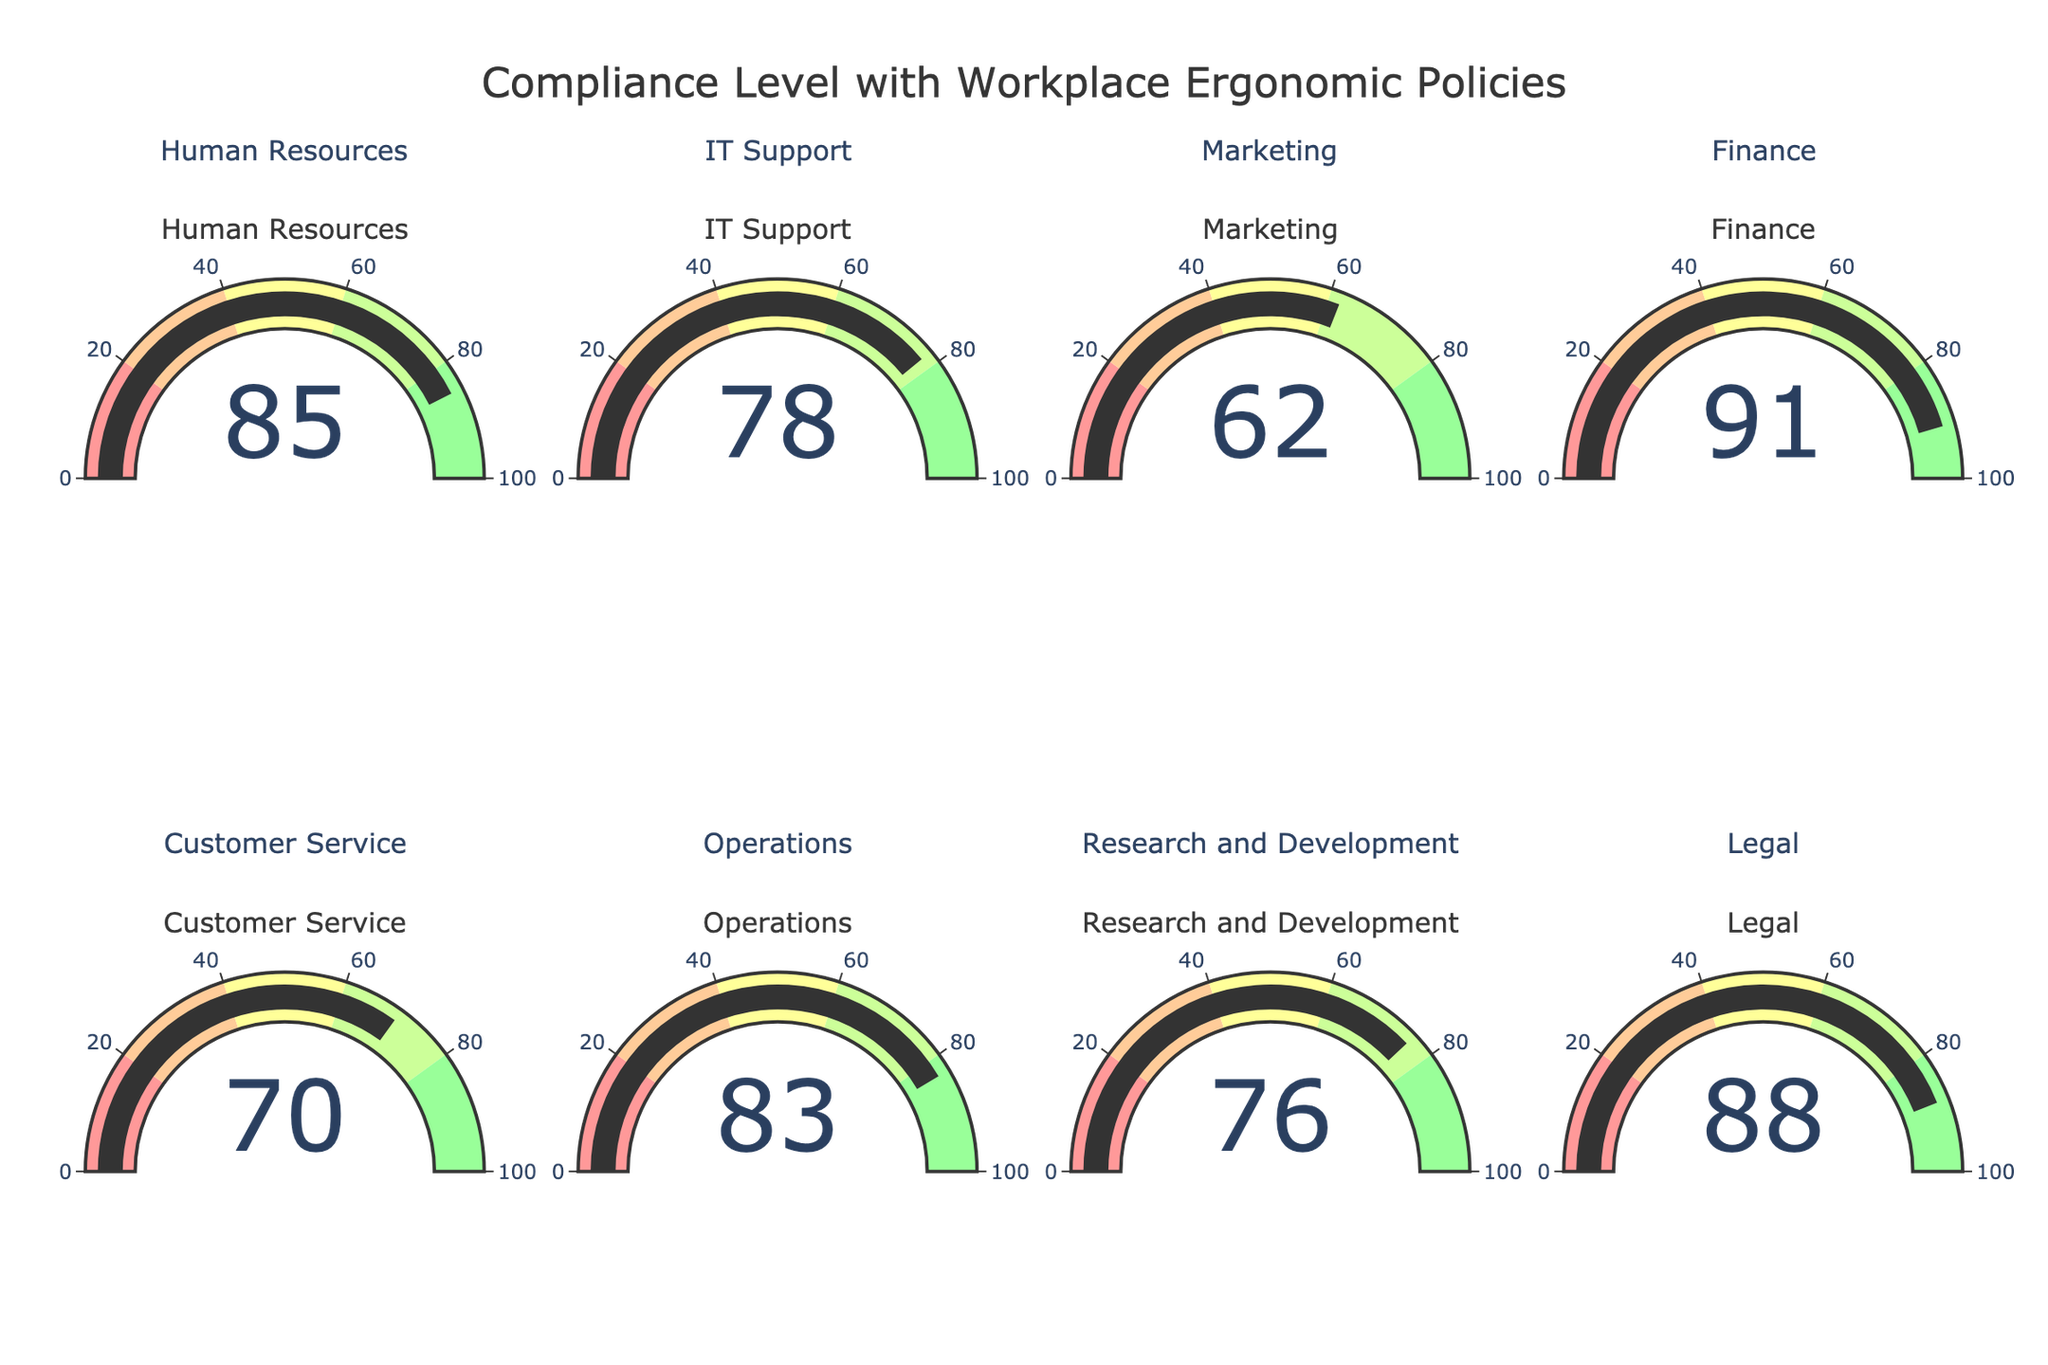What's the average compliance level across all departments? First, sum up the compliance percentages for all departments: 85 (HR) + 78 (IT Support) + 62 (Marketing) + 91 (Finance) + 70 (Customer Service) + 83 (Operations) + 76 (Research and Development) + 88 (Legal) = 633. Then divide by the number of departments, which is 8. So, 633 / 8 = 79.125
Answer: 79.125 Which department has the highest compliance level? Look at the gauge chart and identify the department with the highest percentage. Finance has 91%, which is the highest.
Answer: Finance Compare the compliance levels of IT Support and Marketing. Which department has a higher percentage? IT Support has a compliance percentage of 78, while Marketing has a compliance percentage of 62. 78 is higher than 62.
Answer: IT Support Identify and list the departments with compliance percentages above 80%. From the gauge chart, the departments with values above 80% are Human Resources (85%), Finance (91%), Operations (83%), and Legal (88%).
Answer: Human Resources, Finance, Operations, Legal What is the difference in compliance levels between Customer Service and Research and Development? Customer Service's compliance level is 70%, and Research and Development's compliance level is 76%. The difference is 76 - 70 = 6.
Answer: 6 How many departments have compliance levels between 60% and 80%? From the gauge chart, the departments with compliance levels between 60% and 80% are IT Support (78%), Marketing (62%), Customer Service (70%), and Research and Development (76%). There are 4 such departments.
Answer: 4 What is the title of the figure? The title of the figure as indicated at the top is 'Compliance Level with Workplace Ergonomic Policies'.
Answer: Compliance Level with Workplace Ergonomic Policies Is the compliance level in Legal department closer to the highest compliance level or the average compliance level? The highest compliance level is 91% (Finance), and the average compliance level is 79.125%. Legal's compliance level is 88%, which is closer to 91% than to 79.125%.
Answer: Closer to the highest compliance level What is the range for the green color on the gauge chart? The green color appears in the last range which covers from 80% to 100%.
Answer: 80 to 100 